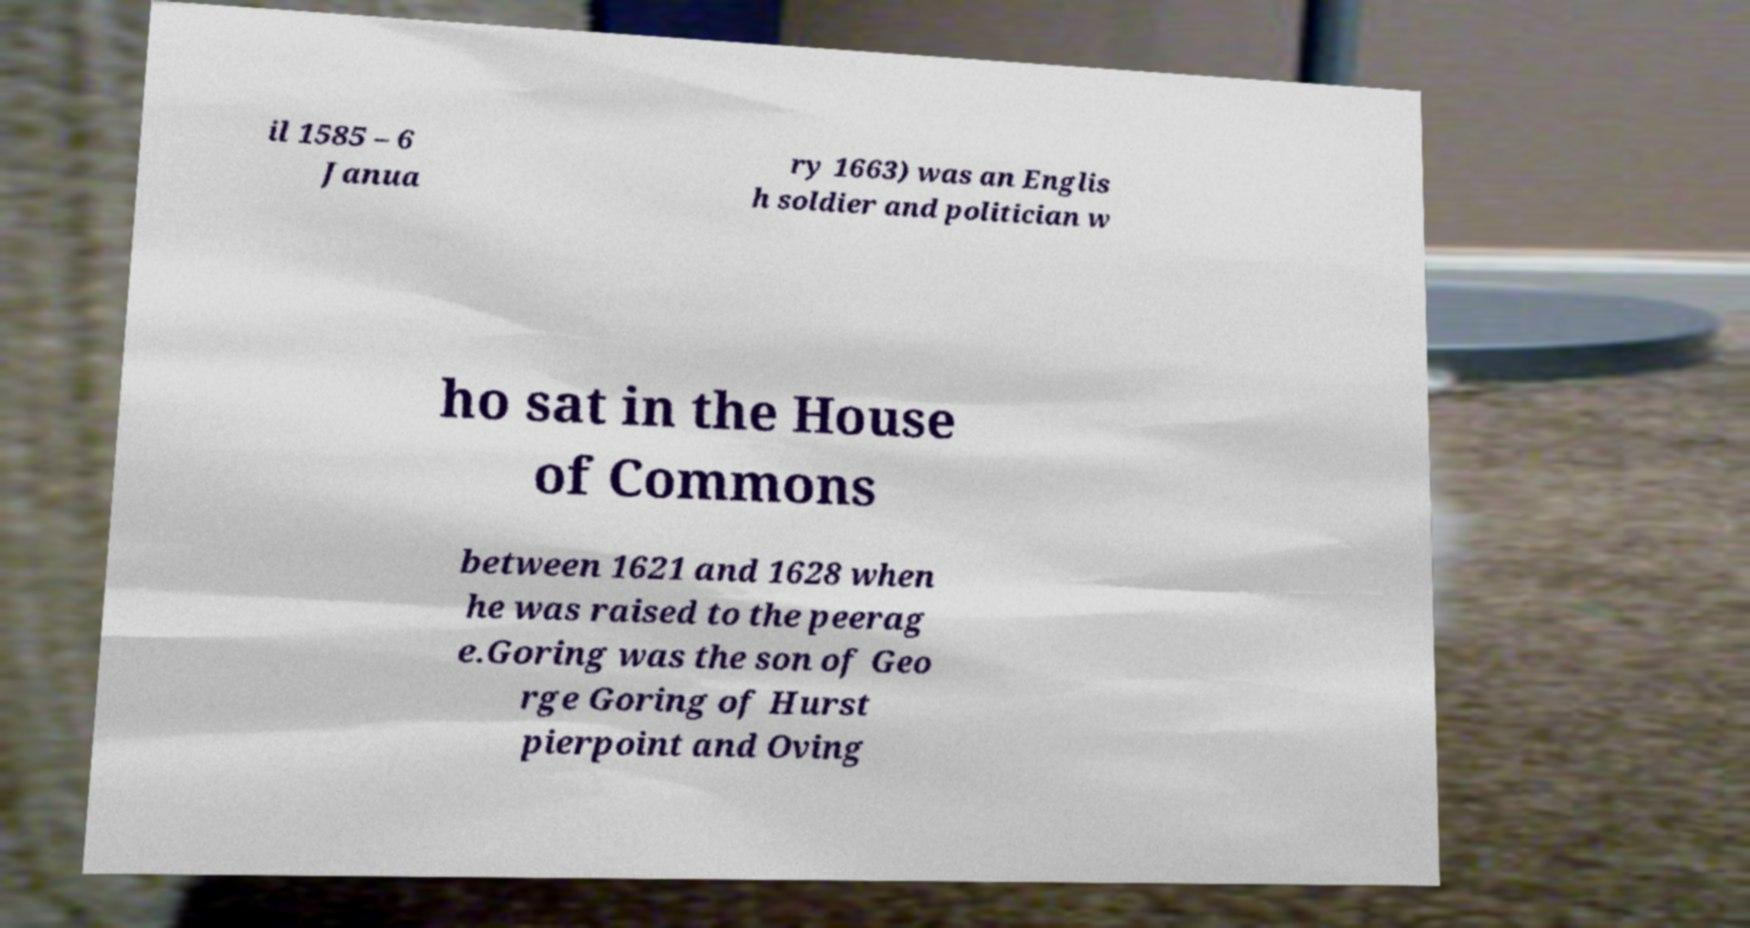Could you extract and type out the text from this image? il 1585 – 6 Janua ry 1663) was an Englis h soldier and politician w ho sat in the House of Commons between 1621 and 1628 when he was raised to the peerag e.Goring was the son of Geo rge Goring of Hurst pierpoint and Oving 